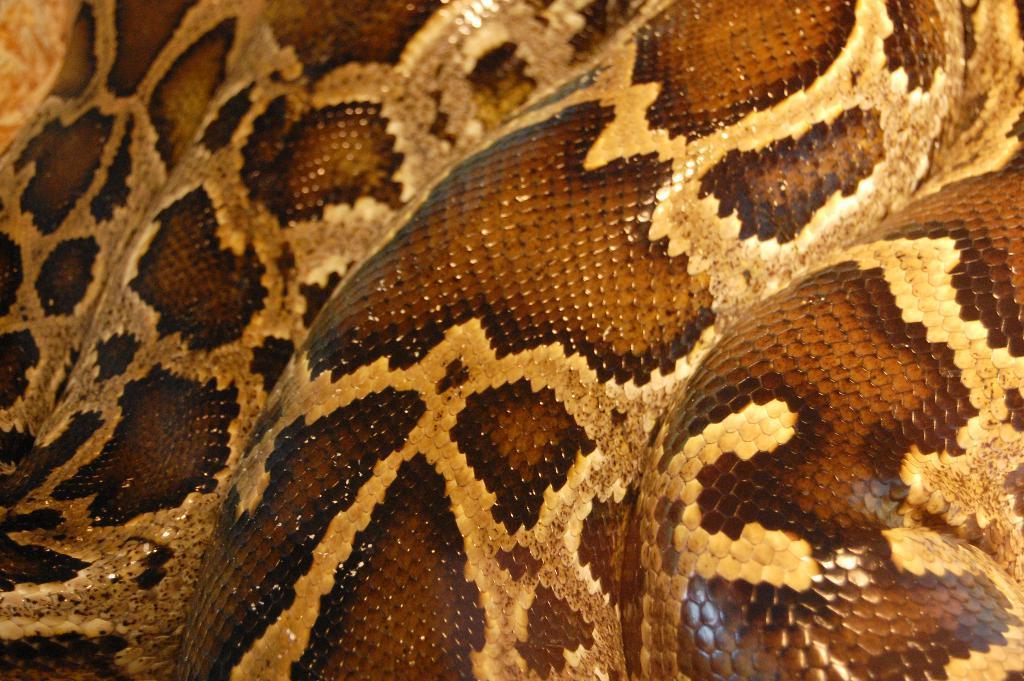Please provide a concise description of this image. In this image I can see a snake skin in brown and cream color. 